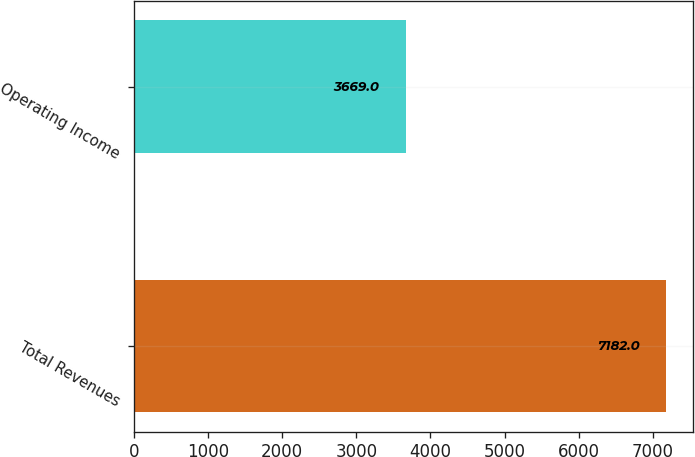Convert chart to OTSL. <chart><loc_0><loc_0><loc_500><loc_500><bar_chart><fcel>Total Revenues<fcel>Operating Income<nl><fcel>7182<fcel>3669<nl></chart> 